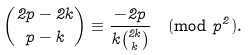<formula> <loc_0><loc_0><loc_500><loc_500>\binom { 2 p - 2 k } { p - k } \equiv \frac { - 2 p } { k \binom { 2 k } k } \pmod { p ^ { 2 } } .</formula> 